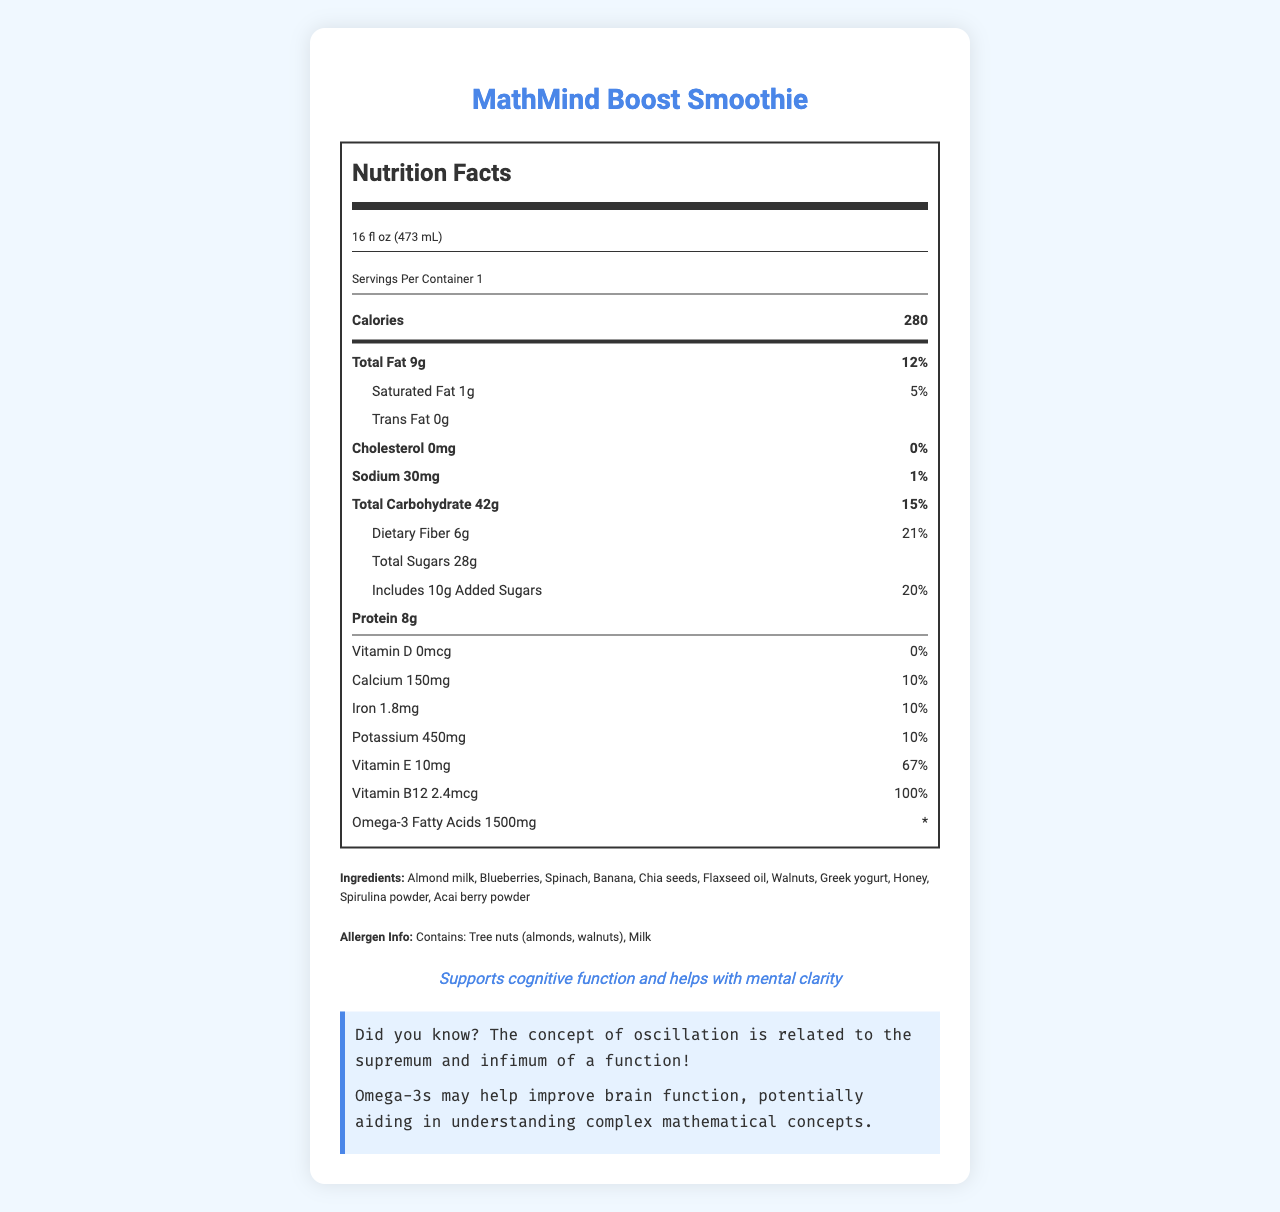what is the serving size of the MathMind Boost Smoothie? The serving size is clearly stated under the product name and is "16 fl oz (473 mL)".
Answer: 16 fl oz (473 mL) how many calories are in a serving of the MathMind Boost Smoothie? The number of calories per serving is indicated right in the center, under the "Calories" section.
Answer: 280 what is the percentage of daily value for Vitamin B12? The daily value for Vitamin B12 is listed as 100% in the nutrition facts label.
Answer: 100% what ingredients does the MathMind Boost Smoothie contain? The ingredient list is provided in the document under the heading "Ingredients".
Answer: Almond milk, Blueberries, Spinach, Banana, Chia seeds, Flaxseed oil, Walnuts, Greek yogurt, Honey, Spirulina powder, Acai berry powder what is the total carbohydrate content and its daily value percentage? The total carbohydrate content is given as 42 grams with a daily value of 15%.
Answer: 42g, 15% which ingredient listed is a tree nut? A. Blueberries B. Almonds C. Honey The allergen information states that the product contains tree nuts (almonds and walnuts), so the correct option is B.
Answer: B what component has a daily value percentage of 0%? A. Cholesterol B. Trans Fat C. Omega-3 Fatty Acids Cholesterol is listed with a daily value of 0%, making A the correct answer.
Answer: A does this product contain Omega-3 Fatty Acids? The nutrition facts clearly list Omega-3 Fatty Acids with an amount of 1500mg.
Answer: Yes what is the main claim about the benefits of this smoothie? The claim is directly stated at the bottom of the document.
Answer: Supports cognitive function and helps with mental clarity summarize the key information presented in the MathMind Boost Smoothie nutrition facts label. The document provides comprehensive nutritional information including calorie count, macro and micronutrients, and percentages of the daily values. It highlights key ingredients and allergens, while also making a health claim regarding cognitive benefits.
Answer: The MathMind Boost Smoothie contains 280 calories per 16 fl oz serving. It has 9g of total fat, 42g of carbohydrates, 8g of protein, and it is rich in vitamins such as Vitamin E and B12. The smoothie is made up of ingredients like almond milk, blueberries, and spinach, and is noted to support cognitive function and mental clarity. The allergen information indicates it contains tree nuts and milk. what percentage of the daily value of dietary fiber does one serving provide? The label lists dietary fiber as providing 21% of the daily value.
Answer: 21% what is the type of fat with the lowest content in this smoothie? Trans Fat is listed as 0g, indicating it has the lowest content.
Answer: Trans Fat does this product contain any cholesterol? The cholesterol amount is listed as 0mg with a daily value of 0%.
Answer: No how does the document describe the relationship between oscillation and a mathematical concept? One of the math facts in the document specifically states this relationship.
Answer: The concept of oscillation is related to the supremum and infimum of a function! what is the source of omega-3 fatty acids in this smoothie? The document mentions the presence of omega-3 fatty acids but does not explicitly list their source(s) among the ingredients provided.
Answer: Not enough information 